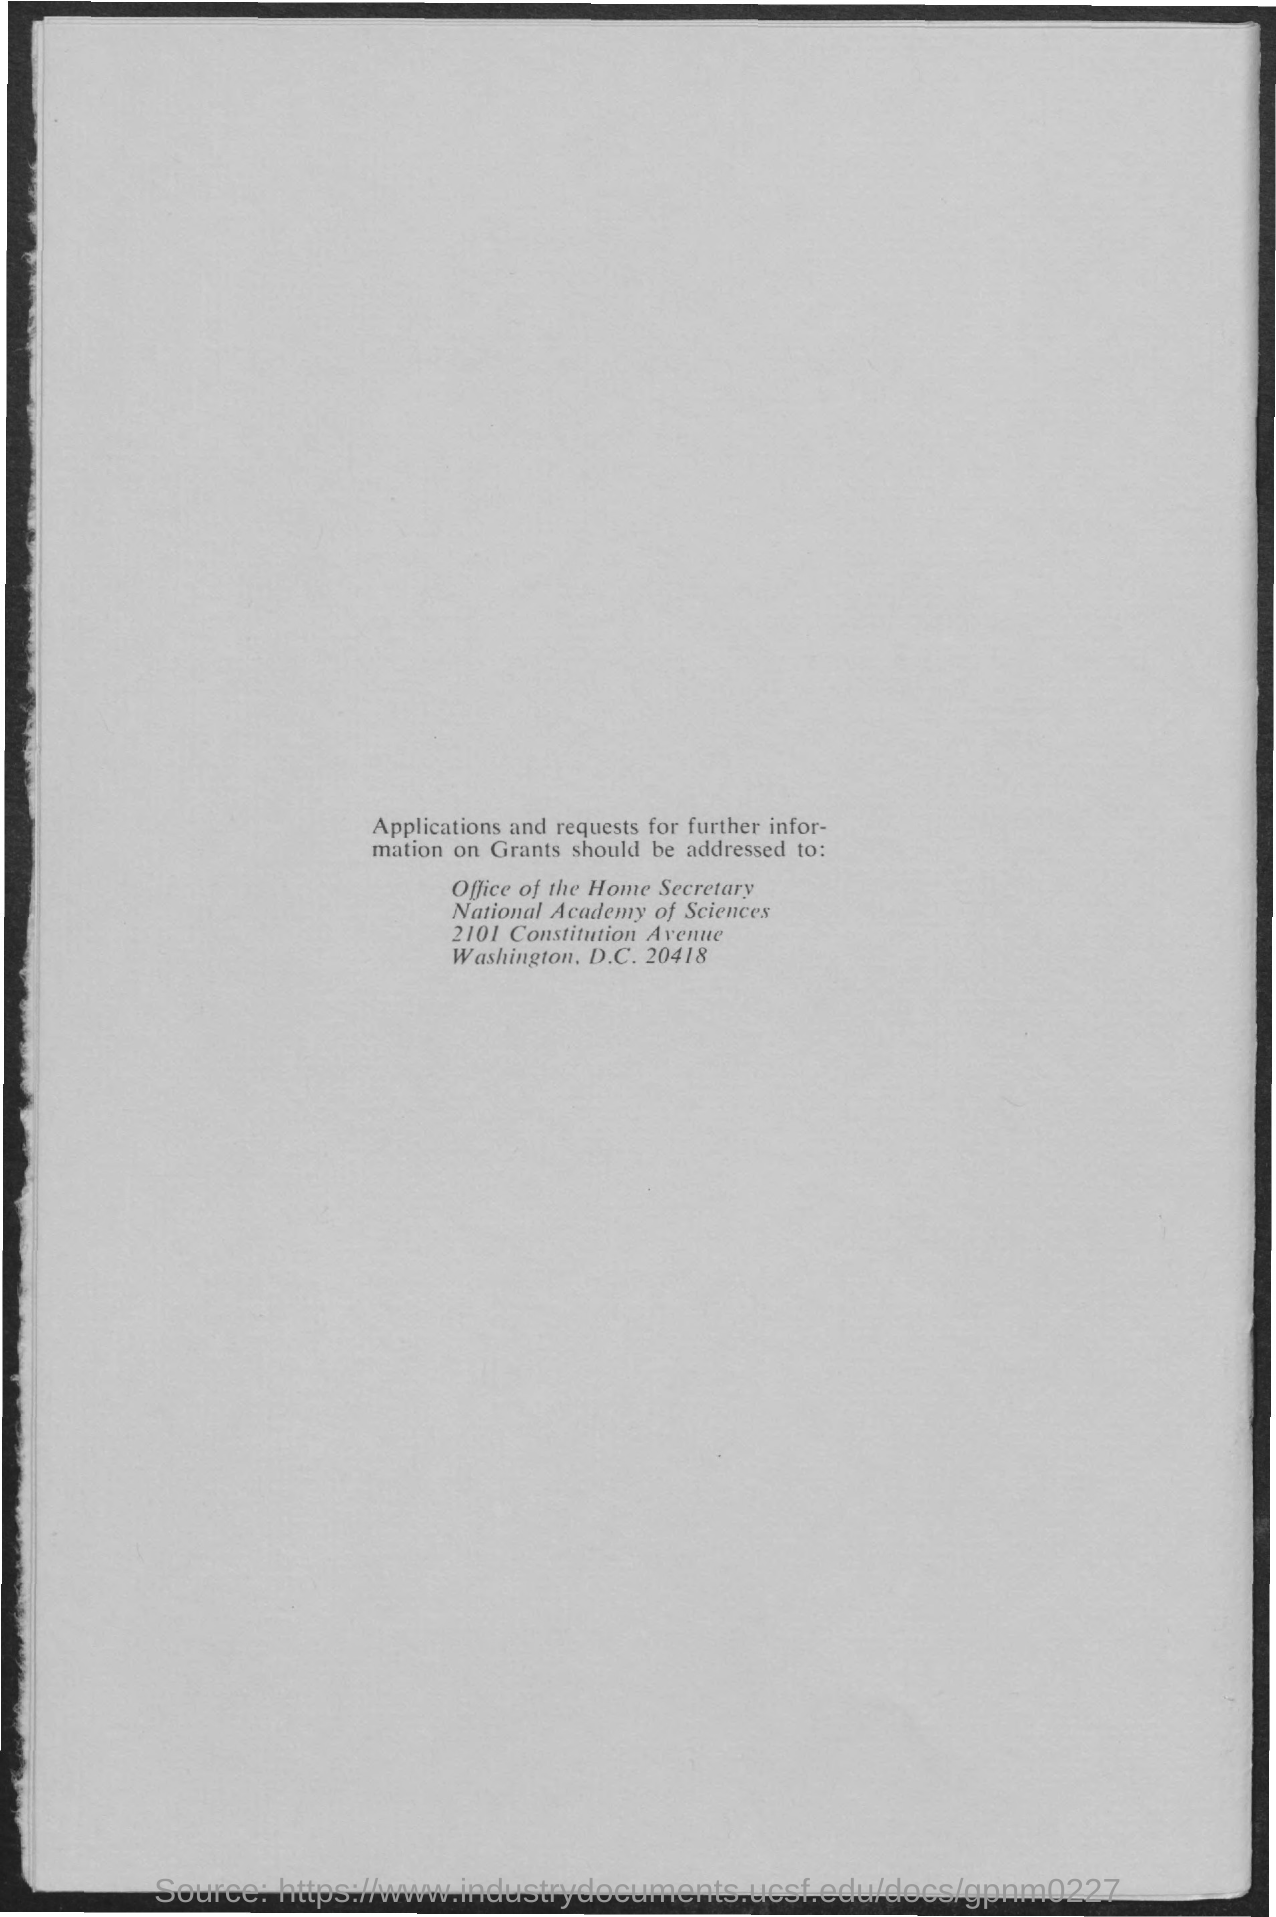What is the name of the academy?
Your answer should be very brief. National Academy of Sciences. What is the zip code of the National academy of science?
Keep it short and to the point. 20418. 